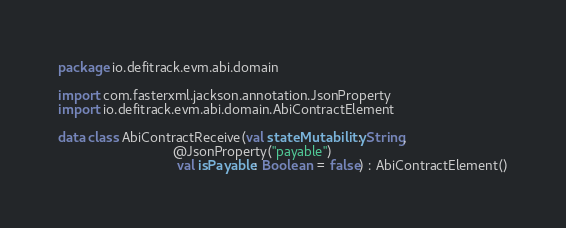<code> <loc_0><loc_0><loc_500><loc_500><_Kotlin_>package io.defitrack.evm.abi.domain

import com.fasterxml.jackson.annotation.JsonProperty
import io.defitrack.evm.abi.domain.AbiContractElement

data class AbiContractReceive(val stateMutability: String,
                              @JsonProperty("payable")
                               val isPayable: Boolean = false) : AbiContractElement()
</code> 